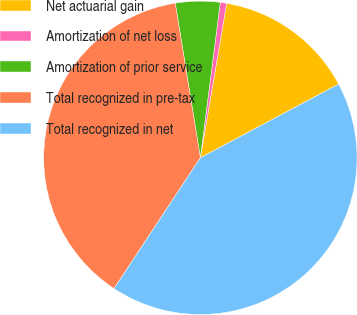Convert chart. <chart><loc_0><loc_0><loc_500><loc_500><pie_chart><fcel>Net actuarial gain<fcel>Amortization of net loss<fcel>Amortization of prior service<fcel>Total recognized in pre-tax<fcel>Total recognized in net<nl><fcel>14.52%<fcel>0.66%<fcel>4.59%<fcel>38.15%<fcel>42.08%<nl></chart> 